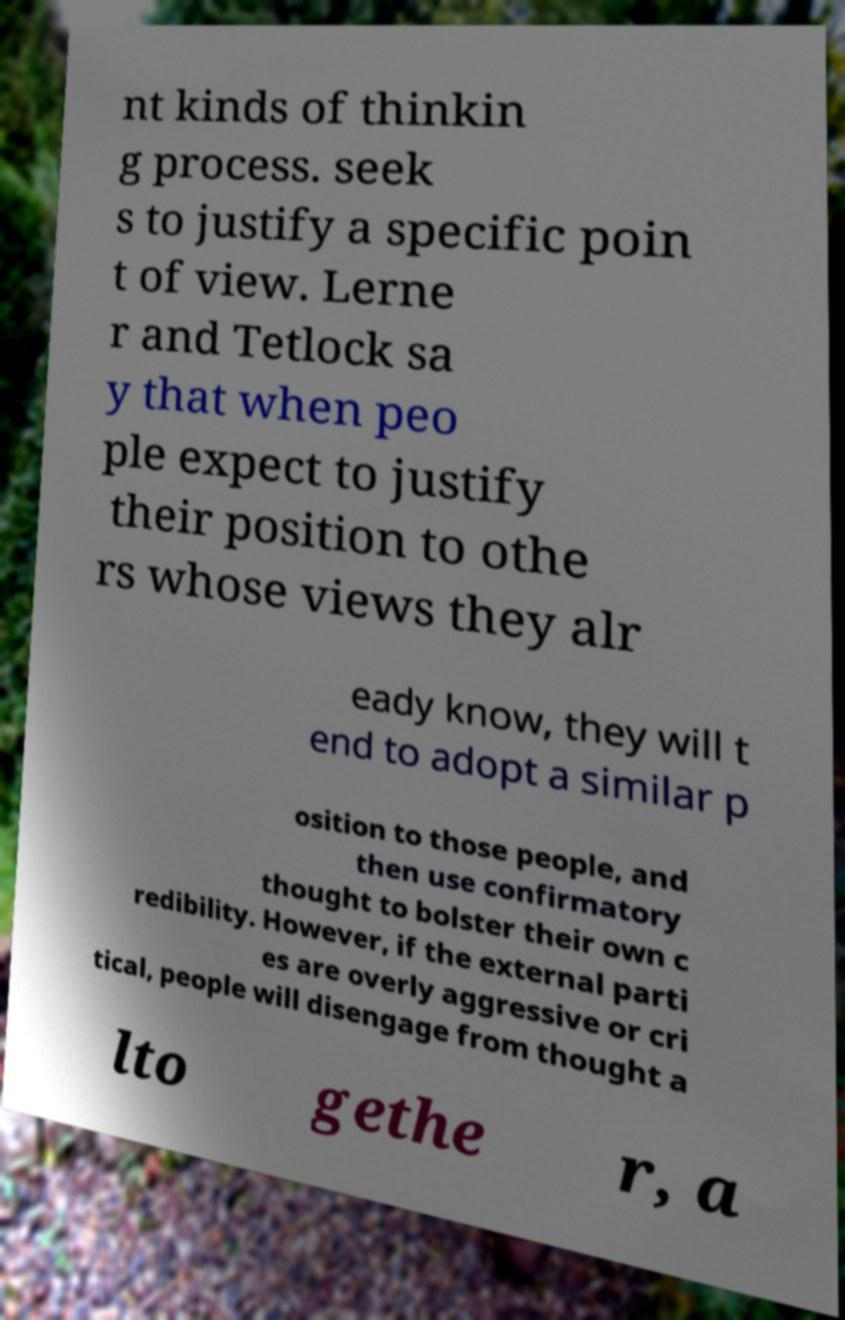Could you assist in decoding the text presented in this image and type it out clearly? nt kinds of thinkin g process. seek s to justify a specific poin t of view. Lerne r and Tetlock sa y that when peo ple expect to justify their position to othe rs whose views they alr eady know, they will t end to adopt a similar p osition to those people, and then use confirmatory thought to bolster their own c redibility. However, if the external parti es are overly aggressive or cri tical, people will disengage from thought a lto gethe r, a 